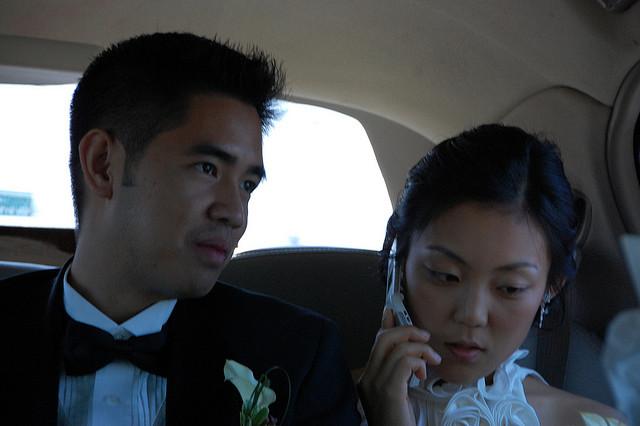Does this man have his seatbelt on?
Be succinct. No. Where is this man going?
Be succinct. Wedding. What is the man's tie pattern?
Answer briefly. Solid. What color hair does the woman on the phone have?
Give a very brief answer. Black. Is the man riding shotgun?
Concise answer only. No. Does the woman have her mouth closed?
Short answer required. No. Is the man from America?
Concise answer only. No. Is the lady talking on the phone?
Write a very short answer. Yes. What emotion is the guy showing?
Keep it brief. Boredom. Is the couple smiling?
Keep it brief. No. Is this woman hungry?
Give a very brief answer. No. What is the man wearing?
Answer briefly. Tuxedo. Are the people going to wed?
Quick response, please. Yes. 